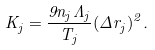<formula> <loc_0><loc_0><loc_500><loc_500>K _ { j } = \frac { 9 n _ { j } \Lambda _ { j } } { T _ { j } } ( \Delta r _ { j } ) ^ { 2 } .</formula> 